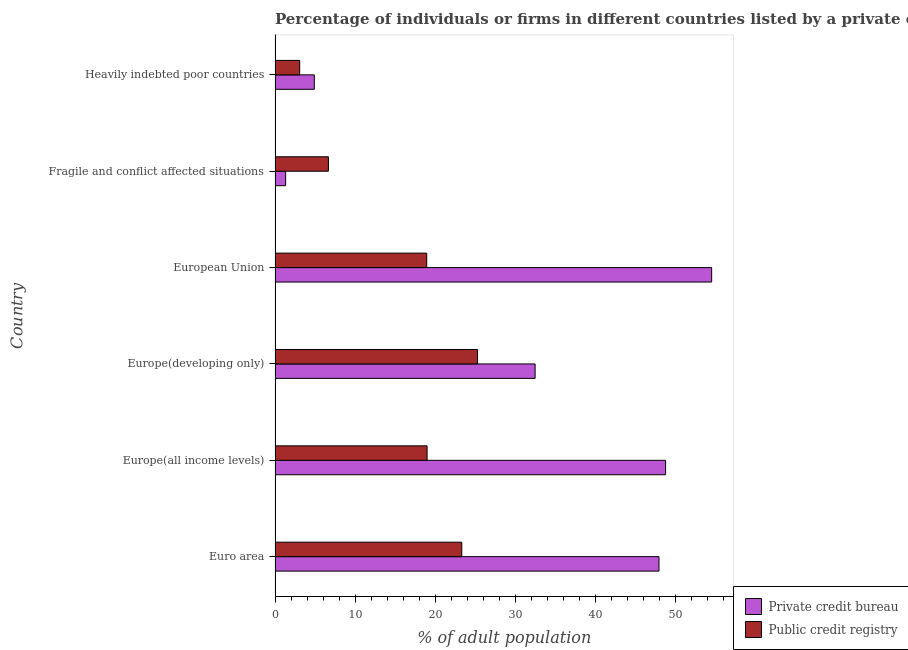Are the number of bars on each tick of the Y-axis equal?
Offer a terse response. Yes. How many bars are there on the 3rd tick from the top?
Ensure brevity in your answer.  2. What is the label of the 2nd group of bars from the top?
Provide a succinct answer. Fragile and conflict affected situations. What is the percentage of firms listed by private credit bureau in Europe(all income levels)?
Give a very brief answer. 48.8. Across all countries, what is the maximum percentage of firms listed by public credit bureau?
Offer a terse response. 25.3. Across all countries, what is the minimum percentage of firms listed by public credit bureau?
Give a very brief answer. 3.07. In which country was the percentage of firms listed by private credit bureau minimum?
Offer a terse response. Fragile and conflict affected situations. What is the total percentage of firms listed by private credit bureau in the graph?
Offer a terse response. 190.05. What is the difference between the percentage of firms listed by public credit bureau in Euro area and that in Fragile and conflict affected situations?
Your answer should be very brief. 16.66. What is the difference between the percentage of firms listed by public credit bureau in Euro area and the percentage of firms listed by private credit bureau in Fragile and conflict affected situations?
Make the answer very short. 22.01. What is the average percentage of firms listed by private credit bureau per country?
Provide a succinct answer. 31.67. What is the difference between the percentage of firms listed by private credit bureau and percentage of firms listed by public credit bureau in Europe(developing only)?
Provide a short and direct response. 7.2. In how many countries, is the percentage of firms listed by public credit bureau greater than 16 %?
Ensure brevity in your answer.  4. What is the ratio of the percentage of firms listed by public credit bureau in Europe(all income levels) to that in Fragile and conflict affected situations?
Your answer should be compact. 2.85. Is the percentage of firms listed by public credit bureau in Euro area less than that in Fragile and conflict affected situations?
Give a very brief answer. No. What is the difference between the highest and the second highest percentage of firms listed by private credit bureau?
Give a very brief answer. 5.76. What is the difference between the highest and the lowest percentage of firms listed by private credit bureau?
Ensure brevity in your answer.  53.24. In how many countries, is the percentage of firms listed by private credit bureau greater than the average percentage of firms listed by private credit bureau taken over all countries?
Offer a terse response. 4. Is the sum of the percentage of firms listed by private credit bureau in Europe(developing only) and European Union greater than the maximum percentage of firms listed by public credit bureau across all countries?
Keep it short and to the point. Yes. What does the 2nd bar from the top in Euro area represents?
Offer a very short reply. Private credit bureau. What does the 1st bar from the bottom in Europe(all income levels) represents?
Make the answer very short. Private credit bureau. How many bars are there?
Offer a terse response. 12. Does the graph contain grids?
Provide a succinct answer. No. Where does the legend appear in the graph?
Keep it short and to the point. Bottom right. What is the title of the graph?
Your response must be concise. Percentage of individuals or firms in different countries listed by a private or public credit bureau. What is the label or title of the X-axis?
Give a very brief answer. % of adult population. What is the % of adult population of Private credit bureau in Euro area?
Your answer should be very brief. 47.97. What is the % of adult population in Public credit registry in Euro area?
Keep it short and to the point. 23.33. What is the % of adult population of Private credit bureau in Europe(all income levels)?
Provide a succinct answer. 48.8. What is the % of adult population of Public credit registry in Europe(all income levels)?
Provide a succinct answer. 18.99. What is the % of adult population in Private credit bureau in Europe(developing only)?
Your answer should be compact. 32.49. What is the % of adult population of Public credit registry in Europe(developing only)?
Make the answer very short. 25.3. What is the % of adult population of Private credit bureau in European Union?
Offer a very short reply. 54.56. What is the % of adult population of Public credit registry in European Union?
Keep it short and to the point. 18.95. What is the % of adult population in Private credit bureau in Fragile and conflict affected situations?
Provide a succinct answer. 1.32. What is the % of adult population in Public credit registry in Fragile and conflict affected situations?
Offer a terse response. 6.67. What is the % of adult population in Private credit bureau in Heavily indebted poor countries?
Keep it short and to the point. 4.9. What is the % of adult population in Public credit registry in Heavily indebted poor countries?
Offer a very short reply. 3.07. Across all countries, what is the maximum % of adult population of Private credit bureau?
Provide a short and direct response. 54.56. Across all countries, what is the maximum % of adult population in Public credit registry?
Offer a very short reply. 25.3. Across all countries, what is the minimum % of adult population of Private credit bureau?
Provide a short and direct response. 1.32. Across all countries, what is the minimum % of adult population of Public credit registry?
Keep it short and to the point. 3.07. What is the total % of adult population in Private credit bureau in the graph?
Make the answer very short. 190.05. What is the total % of adult population of Public credit registry in the graph?
Your answer should be compact. 96.32. What is the difference between the % of adult population in Private credit bureau in Euro area and that in Europe(all income levels)?
Your answer should be very brief. -0.83. What is the difference between the % of adult population in Public credit registry in Euro area and that in Europe(all income levels)?
Make the answer very short. 4.34. What is the difference between the % of adult population of Private credit bureau in Euro area and that in Europe(developing only)?
Offer a very short reply. 15.48. What is the difference between the % of adult population of Public credit registry in Euro area and that in Europe(developing only)?
Your answer should be compact. -1.97. What is the difference between the % of adult population of Private credit bureau in Euro area and that in European Union?
Make the answer very short. -6.58. What is the difference between the % of adult population in Public credit registry in Euro area and that in European Union?
Offer a terse response. 4.38. What is the difference between the % of adult population of Private credit bureau in Euro area and that in Fragile and conflict affected situations?
Provide a succinct answer. 46.66. What is the difference between the % of adult population in Public credit registry in Euro area and that in Fragile and conflict affected situations?
Your response must be concise. 16.66. What is the difference between the % of adult population in Private credit bureau in Euro area and that in Heavily indebted poor countries?
Give a very brief answer. 43.07. What is the difference between the % of adult population in Public credit registry in Euro area and that in Heavily indebted poor countries?
Provide a succinct answer. 20.26. What is the difference between the % of adult population in Private credit bureau in Europe(all income levels) and that in Europe(developing only)?
Ensure brevity in your answer.  16.31. What is the difference between the % of adult population in Public credit registry in Europe(all income levels) and that in Europe(developing only)?
Your response must be concise. -6.31. What is the difference between the % of adult population in Private credit bureau in Europe(all income levels) and that in European Union?
Keep it short and to the point. -5.76. What is the difference between the % of adult population of Public credit registry in Europe(all income levels) and that in European Union?
Your answer should be compact. 0.04. What is the difference between the % of adult population in Private credit bureau in Europe(all income levels) and that in Fragile and conflict affected situations?
Keep it short and to the point. 47.48. What is the difference between the % of adult population in Public credit registry in Europe(all income levels) and that in Fragile and conflict affected situations?
Your answer should be very brief. 12.33. What is the difference between the % of adult population in Private credit bureau in Europe(all income levels) and that in Heavily indebted poor countries?
Your answer should be very brief. 43.9. What is the difference between the % of adult population of Public credit registry in Europe(all income levels) and that in Heavily indebted poor countries?
Offer a terse response. 15.92. What is the difference between the % of adult population in Private credit bureau in Europe(developing only) and that in European Union?
Offer a terse response. -22.06. What is the difference between the % of adult population of Public credit registry in Europe(developing only) and that in European Union?
Your response must be concise. 6.35. What is the difference between the % of adult population of Private credit bureau in Europe(developing only) and that in Fragile and conflict affected situations?
Ensure brevity in your answer.  31.18. What is the difference between the % of adult population in Public credit registry in Europe(developing only) and that in Fragile and conflict affected situations?
Make the answer very short. 18.63. What is the difference between the % of adult population in Private credit bureau in Europe(developing only) and that in Heavily indebted poor countries?
Your response must be concise. 27.59. What is the difference between the % of adult population of Public credit registry in Europe(developing only) and that in Heavily indebted poor countries?
Provide a succinct answer. 22.23. What is the difference between the % of adult population of Private credit bureau in European Union and that in Fragile and conflict affected situations?
Provide a short and direct response. 53.24. What is the difference between the % of adult population in Public credit registry in European Union and that in Fragile and conflict affected situations?
Provide a succinct answer. 12.28. What is the difference between the % of adult population of Private credit bureau in European Union and that in Heavily indebted poor countries?
Provide a short and direct response. 49.66. What is the difference between the % of adult population in Public credit registry in European Union and that in Heavily indebted poor countries?
Offer a very short reply. 15.88. What is the difference between the % of adult population of Private credit bureau in Fragile and conflict affected situations and that in Heavily indebted poor countries?
Your response must be concise. -3.58. What is the difference between the % of adult population in Public credit registry in Fragile and conflict affected situations and that in Heavily indebted poor countries?
Provide a succinct answer. 3.59. What is the difference between the % of adult population of Private credit bureau in Euro area and the % of adult population of Public credit registry in Europe(all income levels)?
Give a very brief answer. 28.98. What is the difference between the % of adult population in Private credit bureau in Euro area and the % of adult population in Public credit registry in Europe(developing only)?
Ensure brevity in your answer.  22.67. What is the difference between the % of adult population in Private credit bureau in Euro area and the % of adult population in Public credit registry in European Union?
Ensure brevity in your answer.  29.02. What is the difference between the % of adult population in Private credit bureau in Euro area and the % of adult population in Public credit registry in Fragile and conflict affected situations?
Your answer should be very brief. 41.31. What is the difference between the % of adult population in Private credit bureau in Euro area and the % of adult population in Public credit registry in Heavily indebted poor countries?
Offer a very short reply. 44.9. What is the difference between the % of adult population in Private credit bureau in Europe(all income levels) and the % of adult population in Public credit registry in European Union?
Ensure brevity in your answer.  29.85. What is the difference between the % of adult population in Private credit bureau in Europe(all income levels) and the % of adult population in Public credit registry in Fragile and conflict affected situations?
Ensure brevity in your answer.  42.13. What is the difference between the % of adult population of Private credit bureau in Europe(all income levels) and the % of adult population of Public credit registry in Heavily indebted poor countries?
Keep it short and to the point. 45.73. What is the difference between the % of adult population of Private credit bureau in Europe(developing only) and the % of adult population of Public credit registry in European Union?
Keep it short and to the point. 13.54. What is the difference between the % of adult population of Private credit bureau in Europe(developing only) and the % of adult population of Public credit registry in Fragile and conflict affected situations?
Keep it short and to the point. 25.83. What is the difference between the % of adult population of Private credit bureau in Europe(developing only) and the % of adult population of Public credit registry in Heavily indebted poor countries?
Provide a succinct answer. 29.42. What is the difference between the % of adult population in Private credit bureau in European Union and the % of adult population in Public credit registry in Fragile and conflict affected situations?
Make the answer very short. 47.89. What is the difference between the % of adult population of Private credit bureau in European Union and the % of adult population of Public credit registry in Heavily indebted poor countries?
Offer a very short reply. 51.48. What is the difference between the % of adult population in Private credit bureau in Fragile and conflict affected situations and the % of adult population in Public credit registry in Heavily indebted poor countries?
Make the answer very short. -1.76. What is the average % of adult population in Private credit bureau per country?
Give a very brief answer. 31.67. What is the average % of adult population of Public credit registry per country?
Provide a short and direct response. 16.05. What is the difference between the % of adult population of Private credit bureau and % of adult population of Public credit registry in Euro area?
Offer a very short reply. 24.64. What is the difference between the % of adult population of Private credit bureau and % of adult population of Public credit registry in Europe(all income levels)?
Provide a short and direct response. 29.81. What is the difference between the % of adult population of Private credit bureau and % of adult population of Public credit registry in Europe(developing only)?
Your answer should be compact. 7.19. What is the difference between the % of adult population in Private credit bureau and % of adult population in Public credit registry in European Union?
Your answer should be very brief. 35.61. What is the difference between the % of adult population in Private credit bureau and % of adult population in Public credit registry in Fragile and conflict affected situations?
Offer a terse response. -5.35. What is the difference between the % of adult population of Private credit bureau and % of adult population of Public credit registry in Heavily indebted poor countries?
Ensure brevity in your answer.  1.83. What is the ratio of the % of adult population in Private credit bureau in Euro area to that in Europe(all income levels)?
Your response must be concise. 0.98. What is the ratio of the % of adult population in Public credit registry in Euro area to that in Europe(all income levels)?
Keep it short and to the point. 1.23. What is the ratio of the % of adult population of Private credit bureau in Euro area to that in Europe(developing only)?
Your response must be concise. 1.48. What is the ratio of the % of adult population of Public credit registry in Euro area to that in Europe(developing only)?
Offer a terse response. 0.92. What is the ratio of the % of adult population in Private credit bureau in Euro area to that in European Union?
Keep it short and to the point. 0.88. What is the ratio of the % of adult population in Public credit registry in Euro area to that in European Union?
Your answer should be compact. 1.23. What is the ratio of the % of adult population of Private credit bureau in Euro area to that in Fragile and conflict affected situations?
Your answer should be very brief. 36.39. What is the ratio of the % of adult population of Public credit registry in Euro area to that in Fragile and conflict affected situations?
Offer a very short reply. 3.5. What is the ratio of the % of adult population of Private credit bureau in Euro area to that in Heavily indebted poor countries?
Keep it short and to the point. 9.79. What is the ratio of the % of adult population of Public credit registry in Euro area to that in Heavily indebted poor countries?
Your response must be concise. 7.59. What is the ratio of the % of adult population in Private credit bureau in Europe(all income levels) to that in Europe(developing only)?
Offer a very short reply. 1.5. What is the ratio of the % of adult population of Public credit registry in Europe(all income levels) to that in Europe(developing only)?
Provide a short and direct response. 0.75. What is the ratio of the % of adult population of Private credit bureau in Europe(all income levels) to that in European Union?
Make the answer very short. 0.89. What is the ratio of the % of adult population of Public credit registry in Europe(all income levels) to that in European Union?
Your answer should be compact. 1. What is the ratio of the % of adult population in Private credit bureau in Europe(all income levels) to that in Fragile and conflict affected situations?
Make the answer very short. 37.02. What is the ratio of the % of adult population in Public credit registry in Europe(all income levels) to that in Fragile and conflict affected situations?
Your answer should be compact. 2.85. What is the ratio of the % of adult population of Private credit bureau in Europe(all income levels) to that in Heavily indebted poor countries?
Your answer should be very brief. 9.96. What is the ratio of the % of adult population of Public credit registry in Europe(all income levels) to that in Heavily indebted poor countries?
Offer a very short reply. 6.18. What is the ratio of the % of adult population of Private credit bureau in Europe(developing only) to that in European Union?
Provide a succinct answer. 0.6. What is the ratio of the % of adult population of Public credit registry in Europe(developing only) to that in European Union?
Offer a very short reply. 1.34. What is the ratio of the % of adult population in Private credit bureau in Europe(developing only) to that in Fragile and conflict affected situations?
Make the answer very short. 24.65. What is the ratio of the % of adult population in Public credit registry in Europe(developing only) to that in Fragile and conflict affected situations?
Offer a terse response. 3.79. What is the ratio of the % of adult population in Private credit bureau in Europe(developing only) to that in Heavily indebted poor countries?
Offer a very short reply. 6.63. What is the ratio of the % of adult population in Public credit registry in Europe(developing only) to that in Heavily indebted poor countries?
Provide a succinct answer. 8.23. What is the ratio of the % of adult population of Private credit bureau in European Union to that in Fragile and conflict affected situations?
Your answer should be very brief. 41.39. What is the ratio of the % of adult population of Public credit registry in European Union to that in Fragile and conflict affected situations?
Offer a very short reply. 2.84. What is the ratio of the % of adult population of Private credit bureau in European Union to that in Heavily indebted poor countries?
Offer a terse response. 11.13. What is the ratio of the % of adult population in Public credit registry in European Union to that in Heavily indebted poor countries?
Provide a short and direct response. 6.17. What is the ratio of the % of adult population in Private credit bureau in Fragile and conflict affected situations to that in Heavily indebted poor countries?
Provide a succinct answer. 0.27. What is the ratio of the % of adult population in Public credit registry in Fragile and conflict affected situations to that in Heavily indebted poor countries?
Keep it short and to the point. 2.17. What is the difference between the highest and the second highest % of adult population in Private credit bureau?
Give a very brief answer. 5.76. What is the difference between the highest and the second highest % of adult population in Public credit registry?
Your response must be concise. 1.97. What is the difference between the highest and the lowest % of adult population of Private credit bureau?
Offer a very short reply. 53.24. What is the difference between the highest and the lowest % of adult population of Public credit registry?
Provide a succinct answer. 22.23. 